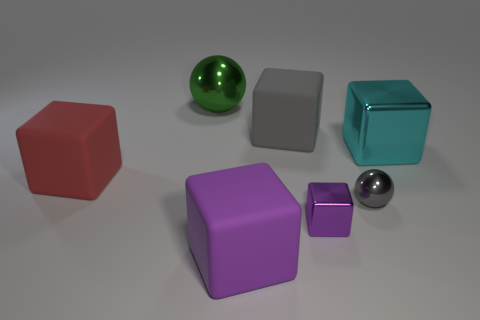Is the size of the gray shiny ball the same as the green ball? no 